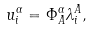<formula> <loc_0><loc_0><loc_500><loc_500>u ^ { \alpha } _ { i } = \Phi ^ { \alpha } _ { A } \lambda ^ { A } _ { i } ,</formula> 